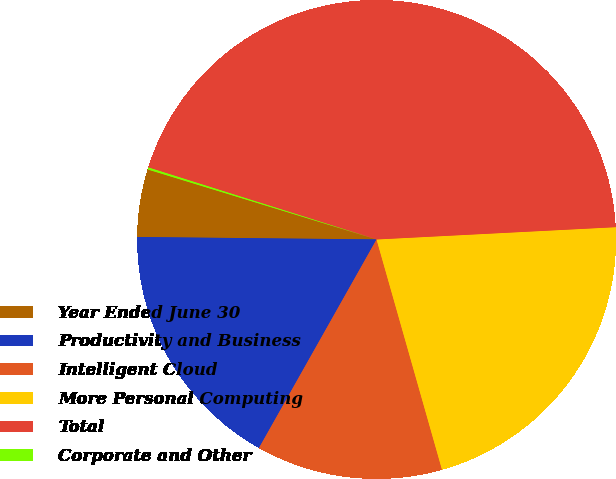Convert chart to OTSL. <chart><loc_0><loc_0><loc_500><loc_500><pie_chart><fcel>Year Ended June 30<fcel>Productivity and Business<fcel>Intelligent Cloud<fcel>More Personal Computing<fcel>Total<fcel>Corporate and Other<nl><fcel>4.56%<fcel>16.99%<fcel>12.58%<fcel>21.41%<fcel>44.32%<fcel>0.14%<nl></chart> 